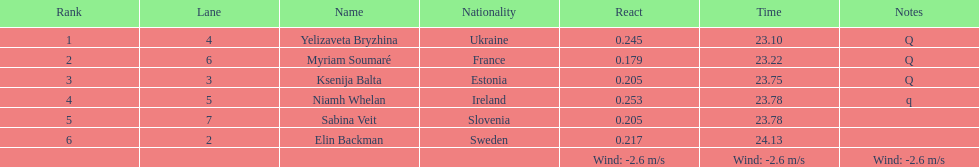After sabina veit, who was the next to finish? Elin Backman. 